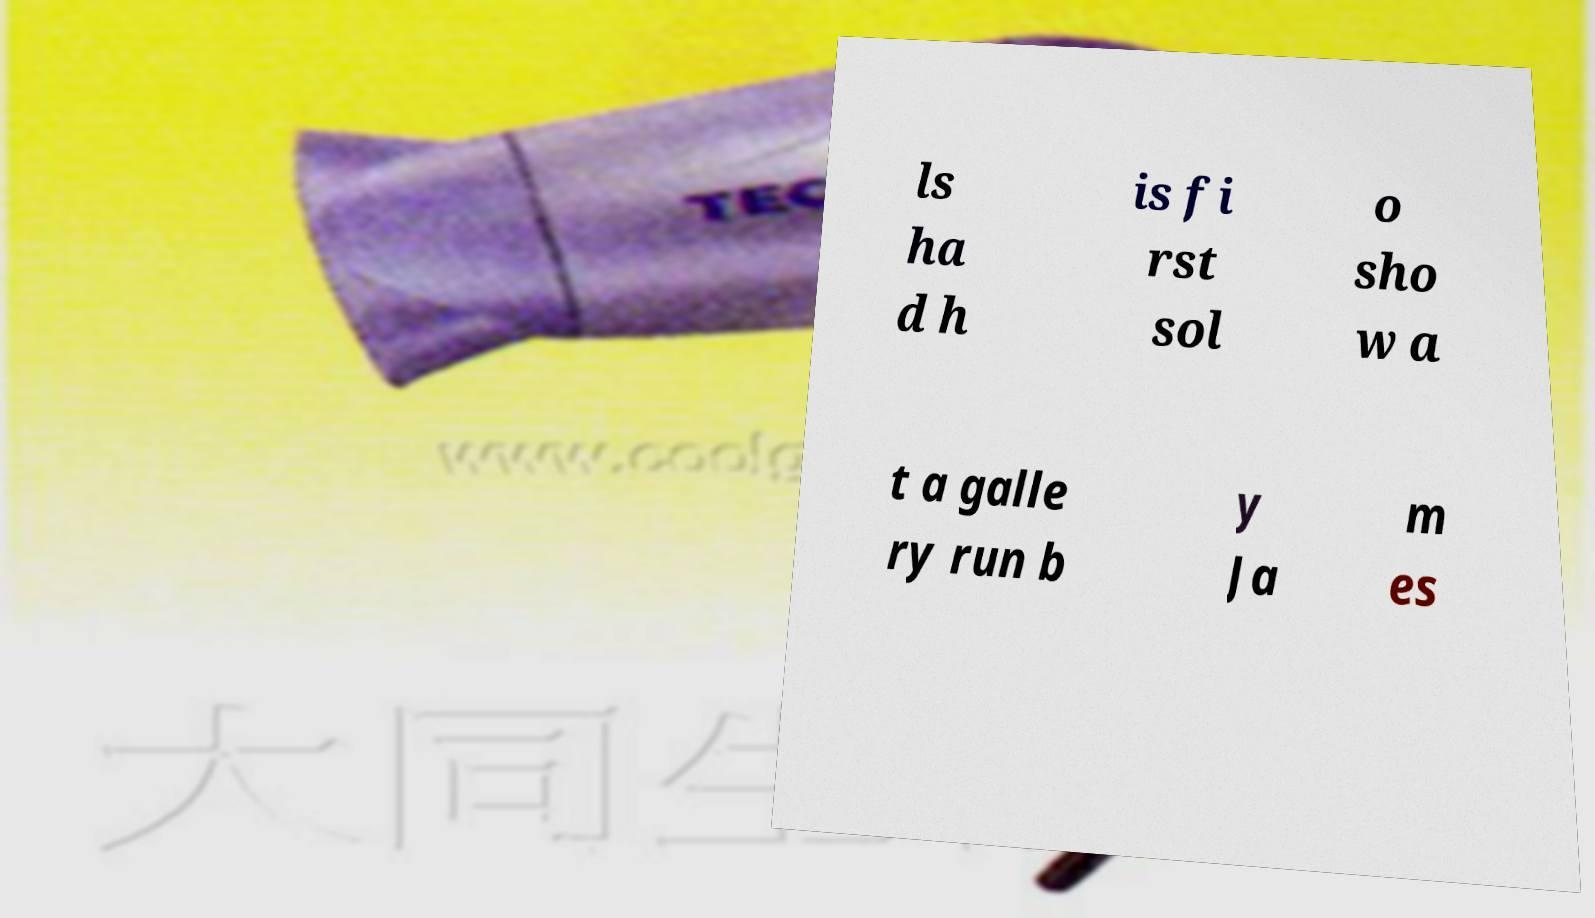Could you extract and type out the text from this image? ls ha d h is fi rst sol o sho w a t a galle ry run b y Ja m es 